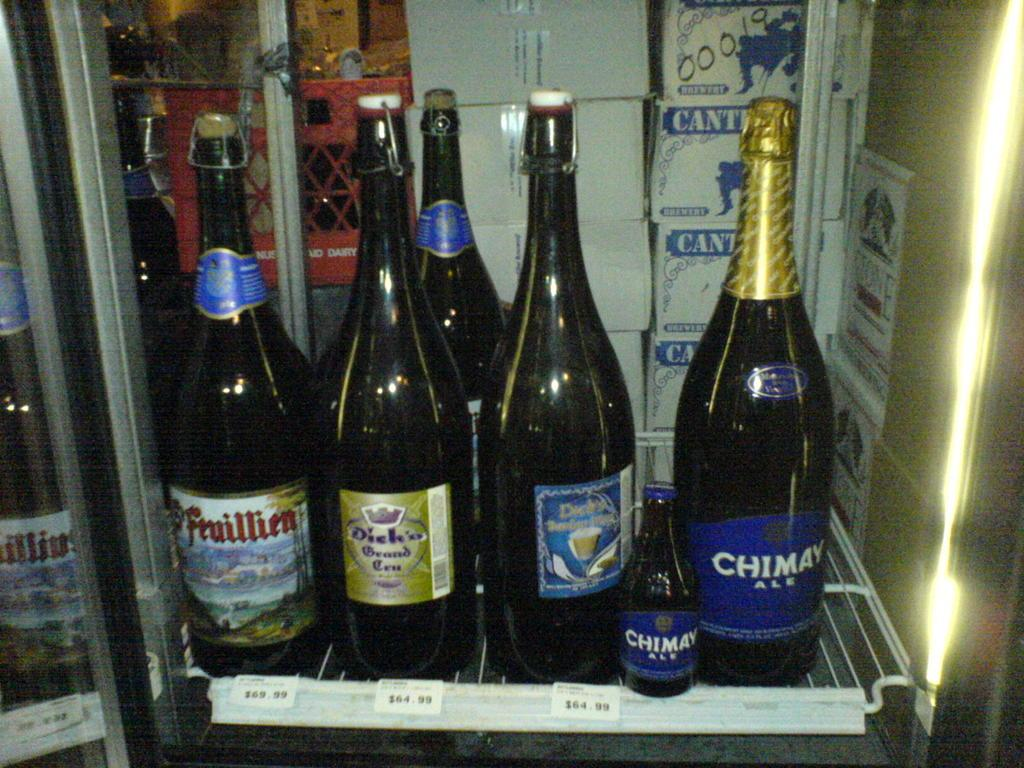<image>
Offer a succinct explanation of the picture presented. A refrigerator contains different beverages like CHIMAY ALE. 